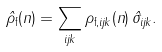Convert formula to latex. <formula><loc_0><loc_0><loc_500><loc_500>\hat { \rho } _ { \text {f} } ( n ) = \sum _ { i j k } \rho _ { \text {f} , i j k } ( n ) \, \hat { \sigma } _ { i j k } .</formula> 